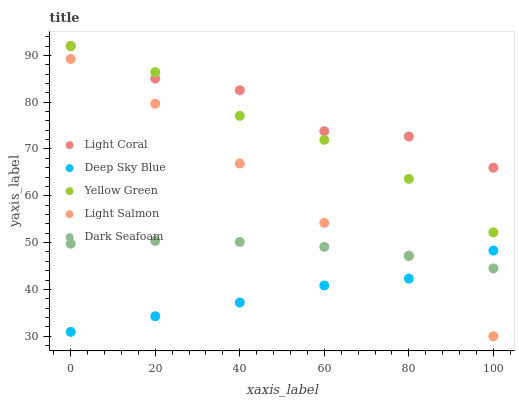Does Deep Sky Blue have the minimum area under the curve?
Answer yes or no. Yes. Does Light Coral have the maximum area under the curve?
Answer yes or no. Yes. Does Light Salmon have the minimum area under the curve?
Answer yes or no. No. Does Light Salmon have the maximum area under the curve?
Answer yes or no. No. Is Dark Seafoam the smoothest?
Answer yes or no. Yes. Is Light Coral the roughest?
Answer yes or no. Yes. Is Light Salmon the smoothest?
Answer yes or no. No. Is Light Salmon the roughest?
Answer yes or no. No. Does Light Salmon have the lowest value?
Answer yes or no. Yes. Does Dark Seafoam have the lowest value?
Answer yes or no. No. Does Yellow Green have the highest value?
Answer yes or no. Yes. Does Light Salmon have the highest value?
Answer yes or no. No. Is Dark Seafoam less than Yellow Green?
Answer yes or no. Yes. Is Yellow Green greater than Dark Seafoam?
Answer yes or no. Yes. Does Yellow Green intersect Light Coral?
Answer yes or no. Yes. Is Yellow Green less than Light Coral?
Answer yes or no. No. Is Yellow Green greater than Light Coral?
Answer yes or no. No. Does Dark Seafoam intersect Yellow Green?
Answer yes or no. No. 